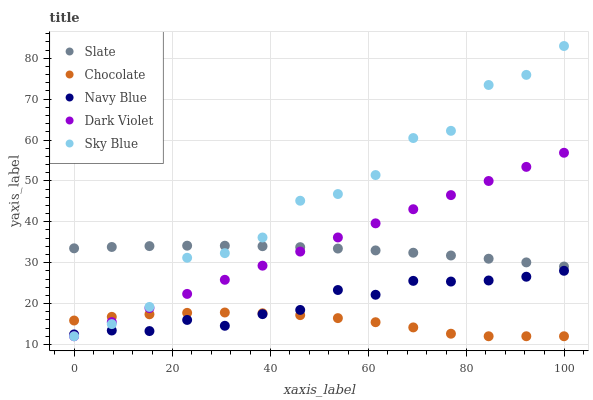Does Chocolate have the minimum area under the curve?
Answer yes or no. Yes. Does Sky Blue have the maximum area under the curve?
Answer yes or no. Yes. Does Navy Blue have the minimum area under the curve?
Answer yes or no. No. Does Navy Blue have the maximum area under the curve?
Answer yes or no. No. Is Dark Violet the smoothest?
Answer yes or no. Yes. Is Sky Blue the roughest?
Answer yes or no. Yes. Is Navy Blue the smoothest?
Answer yes or no. No. Is Navy Blue the roughest?
Answer yes or no. No. Does Sky Blue have the lowest value?
Answer yes or no. Yes. Does Navy Blue have the lowest value?
Answer yes or no. No. Does Sky Blue have the highest value?
Answer yes or no. Yes. Does Navy Blue have the highest value?
Answer yes or no. No. Is Chocolate less than Slate?
Answer yes or no. Yes. Is Slate greater than Chocolate?
Answer yes or no. Yes. Does Sky Blue intersect Navy Blue?
Answer yes or no. Yes. Is Sky Blue less than Navy Blue?
Answer yes or no. No. Is Sky Blue greater than Navy Blue?
Answer yes or no. No. Does Chocolate intersect Slate?
Answer yes or no. No. 